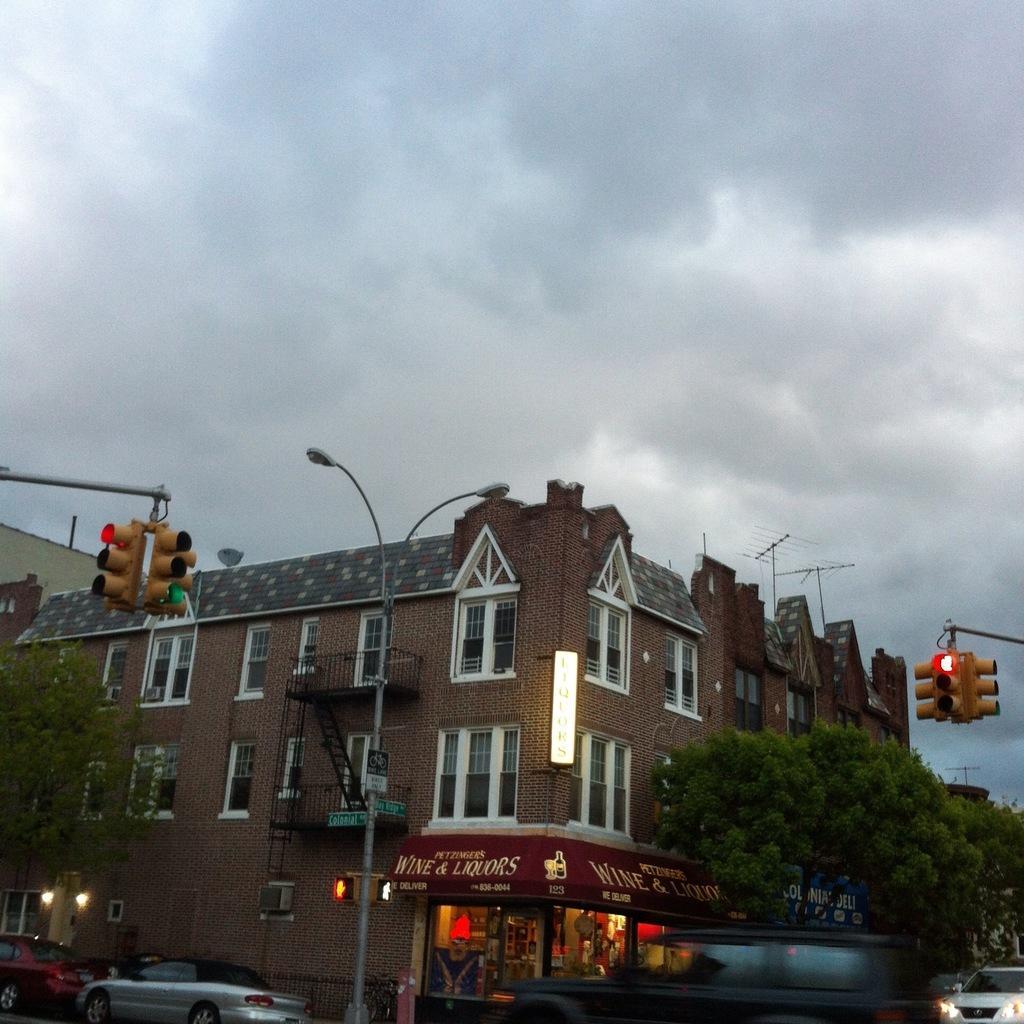Can you describe this image briefly? In this image I can see few vehicles on the bottom side. In the centre of the image I can see number of trees, few poles, few signal lights, few buildings, number of lights, few boards and on these boards I can see something is written. On the top side of the image I can see clouds and the sky. 